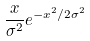<formula> <loc_0><loc_0><loc_500><loc_500>\frac { x } { \sigma ^ { 2 } } e ^ { - x ^ { 2 } / 2 \sigma ^ { 2 } }</formula> 